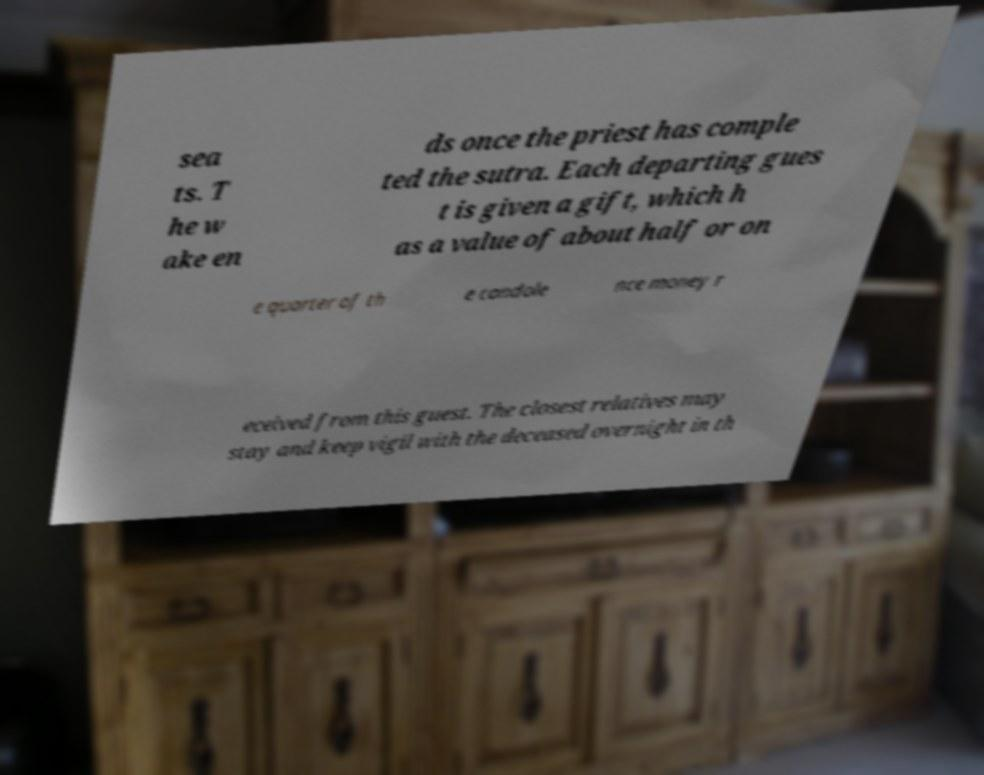Can you accurately transcribe the text from the provided image for me? sea ts. T he w ake en ds once the priest has comple ted the sutra. Each departing gues t is given a gift, which h as a value of about half or on e quarter of th e condole nce money r eceived from this guest. The closest relatives may stay and keep vigil with the deceased overnight in th 